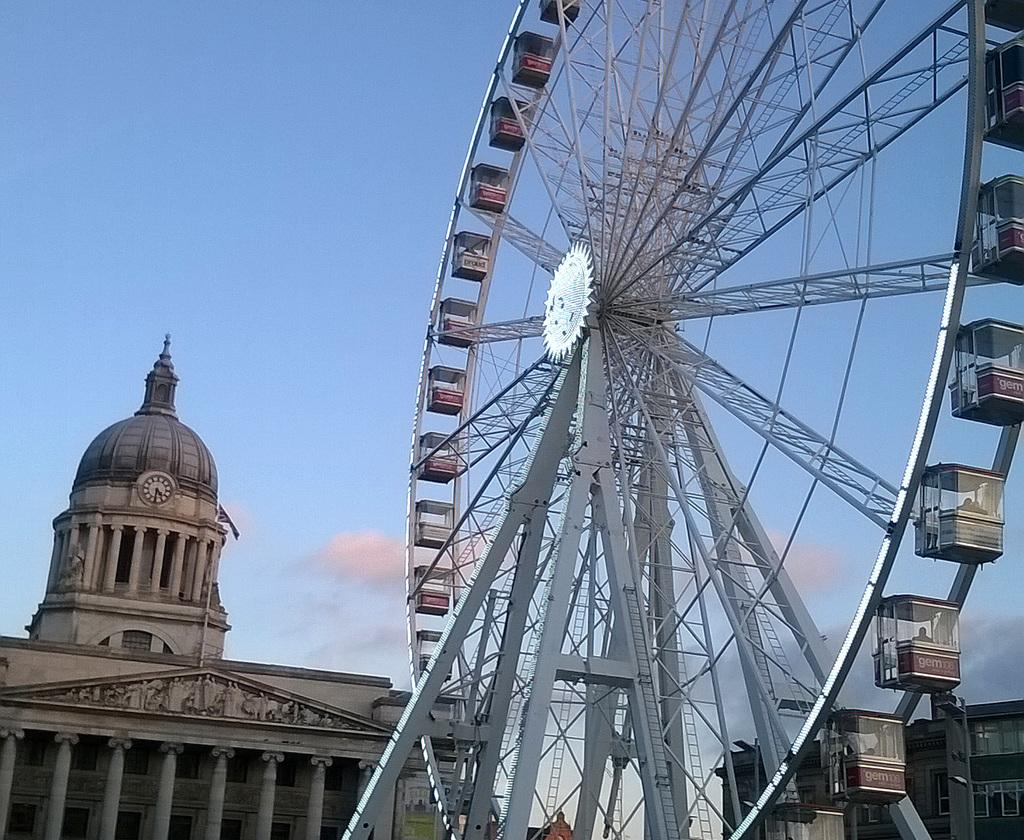What is the main attraction in the image? There is a Ferris wheel in the image. What else can be seen in the image besides the Ferris wheel? There are buildings in the image. What can be seen in the background of the image? The sky is visible in the background of the image. What type of brick is used to construct the ground in the image? There is no mention of a ground or any brick in the image; it primarily features a Ferris wheel and buildings. 